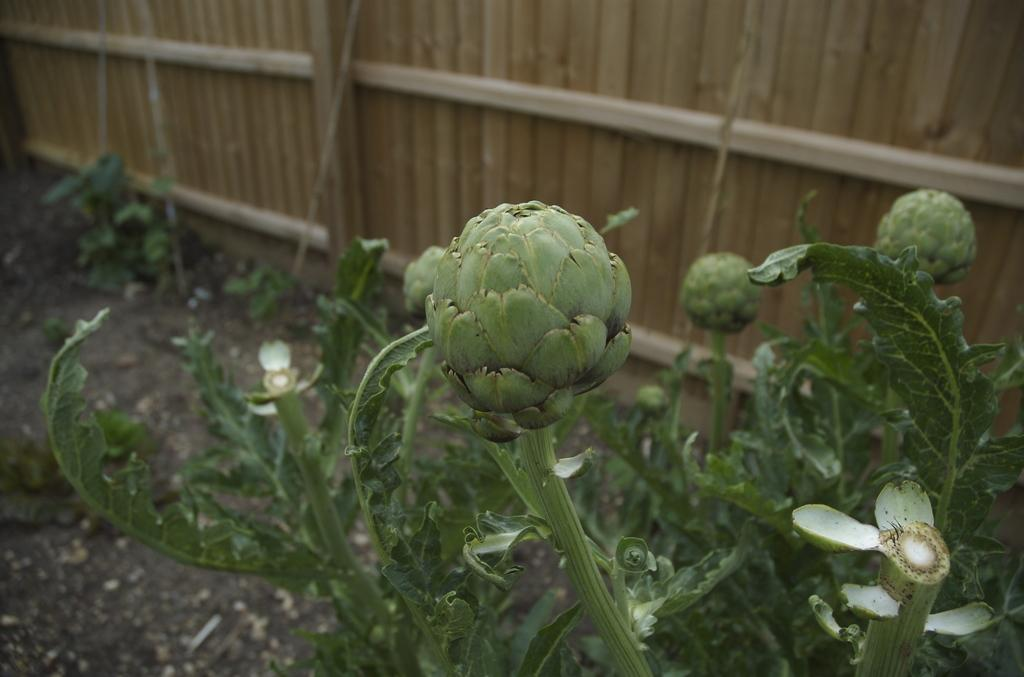What type of plants can be seen on the ground in the image? There are plants with fruits and vegetables on the right side of the image, and other plants on the left side of the image. What can be seen in the background of the image? There is a wooden wall in the background of the image. How does the fan contribute to the discussion in the image? There is no fan present in the image, and therefore it cannot contribute to any discussion. 